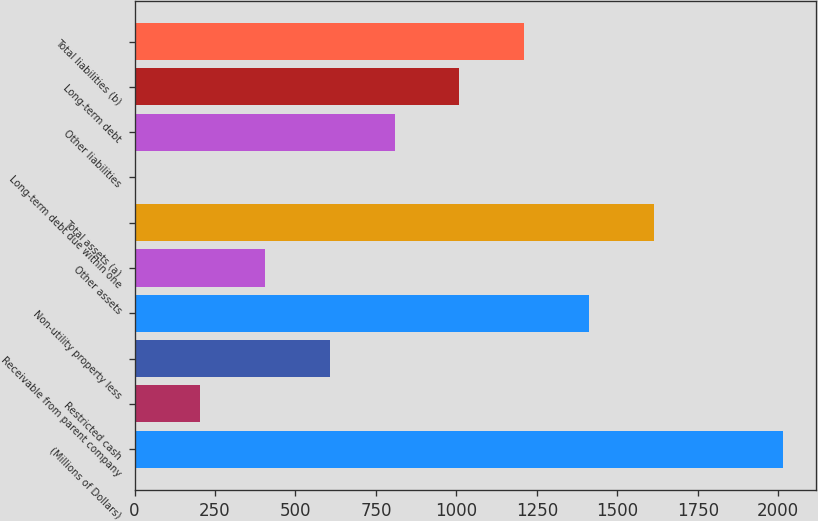Convert chart to OTSL. <chart><loc_0><loc_0><loc_500><loc_500><bar_chart><fcel>(Millions of Dollars)<fcel>Restricted cash<fcel>Receivable from parent company<fcel>Non-utility property less<fcel>Other assets<fcel>Total assets (a)<fcel>Long-term debt due within one<fcel>Other liabilities<fcel>Long-term debt<fcel>Total liabilities (b)<nl><fcel>2016<fcel>204.3<fcel>606.9<fcel>1412.1<fcel>405.6<fcel>1613.4<fcel>3<fcel>808.2<fcel>1009.5<fcel>1210.8<nl></chart> 